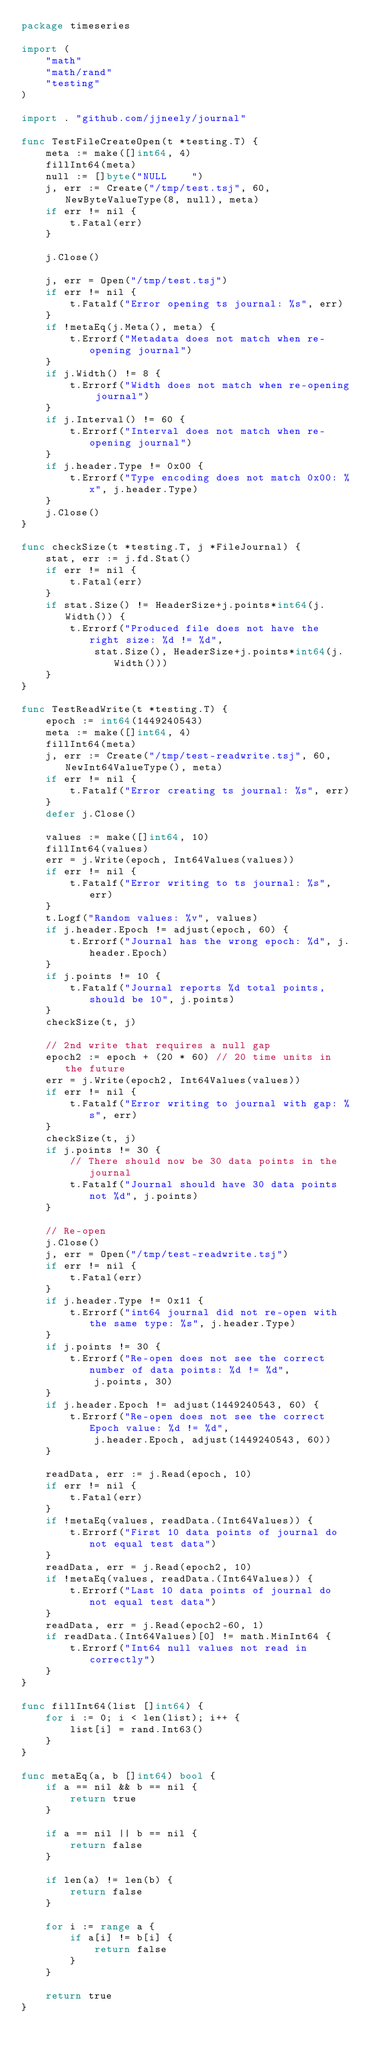<code> <loc_0><loc_0><loc_500><loc_500><_Go_>package timeseries

import (
	"math"
	"math/rand"
	"testing"
)

import . "github.com/jjneely/journal"

func TestFileCreateOpen(t *testing.T) {
	meta := make([]int64, 4)
	fillInt64(meta)
	null := []byte("NULL    ")
	j, err := Create("/tmp/test.tsj", 60, NewByteValueType(8, null), meta)
	if err != nil {
		t.Fatal(err)
	}

	j.Close()

	j, err = Open("/tmp/test.tsj")
	if err != nil {
		t.Fatalf("Error opening ts journal: %s", err)
	}
	if !metaEq(j.Meta(), meta) {
		t.Errorf("Metadata does not match when re-opening journal")
	}
	if j.Width() != 8 {
		t.Errorf("Width does not match when re-opening journal")
	}
	if j.Interval() != 60 {
		t.Errorf("Interval does not match when re-opening journal")
	}
	if j.header.Type != 0x00 {
		t.Errorf("Type encoding does not match 0x00: %x", j.header.Type)
	}
	j.Close()
}

func checkSize(t *testing.T, j *FileJournal) {
	stat, err := j.fd.Stat()
	if err != nil {
		t.Fatal(err)
	}
	if stat.Size() != HeaderSize+j.points*int64(j.Width()) {
		t.Errorf("Produced file does not have the right size: %d != %d",
			stat.Size(), HeaderSize+j.points*int64(j.Width()))
	}
}

func TestReadWrite(t *testing.T) {
	epoch := int64(1449240543)
	meta := make([]int64, 4)
	fillInt64(meta)
	j, err := Create("/tmp/test-readwrite.tsj", 60, NewInt64ValueType(), meta)
	if err != nil {
		t.Fatalf("Error creating ts journal: %s", err)
	}
	defer j.Close()

	values := make([]int64, 10)
	fillInt64(values)
	err = j.Write(epoch, Int64Values(values))
	if err != nil {
		t.Fatalf("Error writing to ts journal: %s", err)
	}
	t.Logf("Random values: %v", values)
	if j.header.Epoch != adjust(epoch, 60) {
		t.Errorf("Journal has the wrong epoch: %d", j.header.Epoch)
	}
	if j.points != 10 {
		t.Fatalf("Journal reports %d total points, should be 10", j.points)
	}
	checkSize(t, j)

	// 2nd write that requires a null gap
	epoch2 := epoch + (20 * 60) // 20 time units in the future
	err = j.Write(epoch2, Int64Values(values))
	if err != nil {
		t.Fatalf("Error writing to journal with gap: %s", err)
	}
	checkSize(t, j)
	if j.points != 30 {
		// There should now be 30 data points in the journal
		t.Fatalf("Journal should have 30 data points not %d", j.points)
	}

	// Re-open
	j.Close()
	j, err = Open("/tmp/test-readwrite.tsj")
	if err != nil {
		t.Fatal(err)
	}
	if j.header.Type != 0x11 {
		t.Errorf("int64 journal did not re-open with the same type: %s", j.header.Type)
	}
	if j.points != 30 {
		t.Errorf("Re-open does not see the correct number of data points: %d != %d",
			j.points, 30)
	}
	if j.header.Epoch != adjust(1449240543, 60) {
		t.Errorf("Re-open does not see the correct Epoch value: %d != %d",
			j.header.Epoch, adjust(1449240543, 60))
	}

	readData, err := j.Read(epoch, 10)
	if err != nil {
		t.Fatal(err)
	}
	if !metaEq(values, readData.(Int64Values)) {
		t.Errorf("First 10 data points of journal do not equal test data")
	}
	readData, err = j.Read(epoch2, 10)
	if !metaEq(values, readData.(Int64Values)) {
		t.Errorf("Last 10 data points of journal do not equal test data")
	}
	readData, err = j.Read(epoch2-60, 1)
	if readData.(Int64Values)[0] != math.MinInt64 {
		t.Errorf("Int64 null values not read in correctly")
	}
}

func fillInt64(list []int64) {
	for i := 0; i < len(list); i++ {
		list[i] = rand.Int63()
	}
}

func metaEq(a, b []int64) bool {
	if a == nil && b == nil {
		return true
	}

	if a == nil || b == nil {
		return false
	}

	if len(a) != len(b) {
		return false
	}

	for i := range a {
		if a[i] != b[i] {
			return false
		}
	}

	return true
}
</code> 